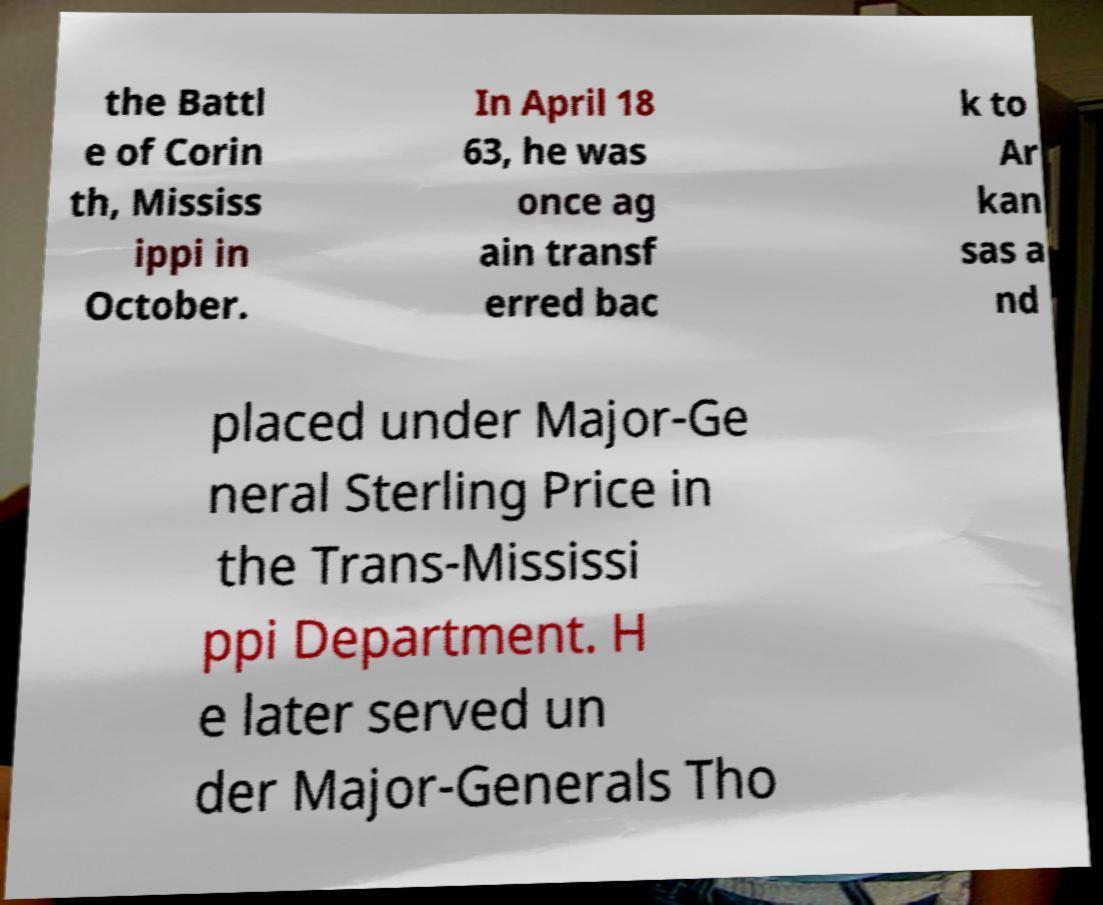Please identify and transcribe the text found in this image. the Battl e of Corin th, Mississ ippi in October. In April 18 63, he was once ag ain transf erred bac k to Ar kan sas a nd placed under Major-Ge neral Sterling Price in the Trans-Mississi ppi Department. H e later served un der Major-Generals Tho 